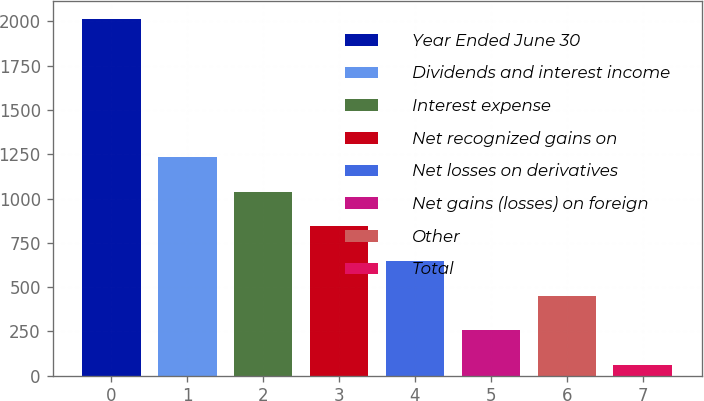<chart> <loc_0><loc_0><loc_500><loc_500><bar_chart><fcel>Year Ended June 30<fcel>Dividends and interest income<fcel>Interest expense<fcel>Net recognized gains on<fcel>Net losses on derivatives<fcel>Net gains (losses) on foreign<fcel>Other<fcel>Total<nl><fcel>2014<fcel>1232.8<fcel>1037.5<fcel>842.2<fcel>646.9<fcel>256.3<fcel>451.6<fcel>61<nl></chart> 